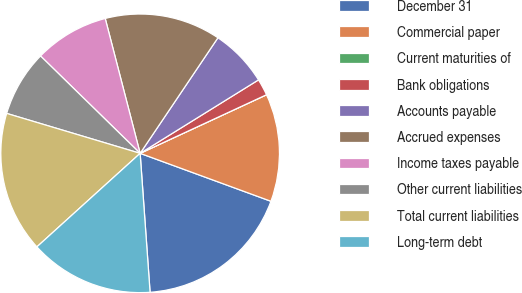Convert chart to OTSL. <chart><loc_0><loc_0><loc_500><loc_500><pie_chart><fcel>December 31<fcel>Commercial paper<fcel>Current maturities of<fcel>Bank obligations<fcel>Accounts payable<fcel>Accrued expenses<fcel>Income taxes payable<fcel>Other current liabilities<fcel>Total current liabilities<fcel>Long-term debt<nl><fcel>18.27%<fcel>12.5%<fcel>0.0%<fcel>1.93%<fcel>6.73%<fcel>13.46%<fcel>8.65%<fcel>7.69%<fcel>16.34%<fcel>14.42%<nl></chart> 